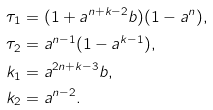Convert formula to latex. <formula><loc_0><loc_0><loc_500><loc_500>\tau _ { 1 } & = ( 1 + a ^ { n + k - 2 } b ) ( 1 - a ^ { n } ) , \\ \tau _ { 2 } & = a ^ { n - 1 } ( 1 - a ^ { k - 1 } ) , \\ k _ { 1 } & = a ^ { 2 n + k - 3 } b , \\ k _ { 2 } & = a ^ { n - 2 } .</formula> 